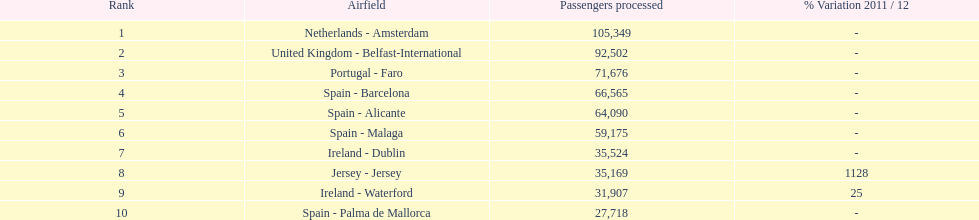Would you be able to parse every entry in this table? {'header': ['Rank', 'Airfield', 'Passengers processed', '% Variation 2011 / 12'], 'rows': [['1', 'Netherlands - Amsterdam', '105,349', '-'], ['2', 'United Kingdom - Belfast-International', '92,502', '-'], ['3', 'Portugal - Faro', '71,676', '-'], ['4', 'Spain - Barcelona', '66,565', '-'], ['5', 'Spain - Alicante', '64,090', '-'], ['6', 'Spain - Malaga', '59,175', '-'], ['7', 'Ireland - Dublin', '35,524', '-'], ['8', 'Jersey - Jersey', '35,169', '1128'], ['9', 'Ireland - Waterford', '31,907', '25'], ['10', 'Spain - Palma de Mallorca', '27,718', '-']]} Which airport had more passengers handled than the united kingdom? Netherlands - Amsterdam. 